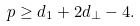Convert formula to latex. <formula><loc_0><loc_0><loc_500><loc_500>p \geq d _ { 1 } + 2 d _ { \perp } - 4 .</formula> 